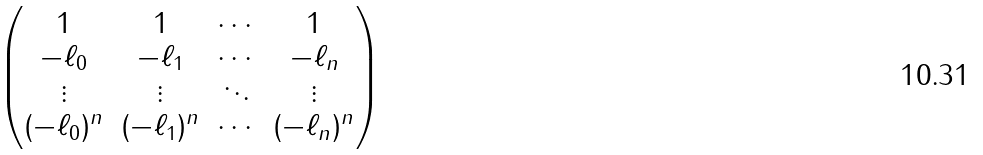Convert formula to latex. <formula><loc_0><loc_0><loc_500><loc_500>\begin{pmatrix} 1 & 1 & \cdots & 1 \\ - \ell _ { 0 } & - \ell _ { 1 } & \cdots & - \ell _ { n } \\ \vdots & \vdots & \ddots & \vdots \\ ( - \ell _ { 0 } ) ^ { n } & ( - \ell _ { 1 } ) ^ { n } & \cdots & ( - \ell _ { n } ) ^ { n } \end{pmatrix}</formula> 